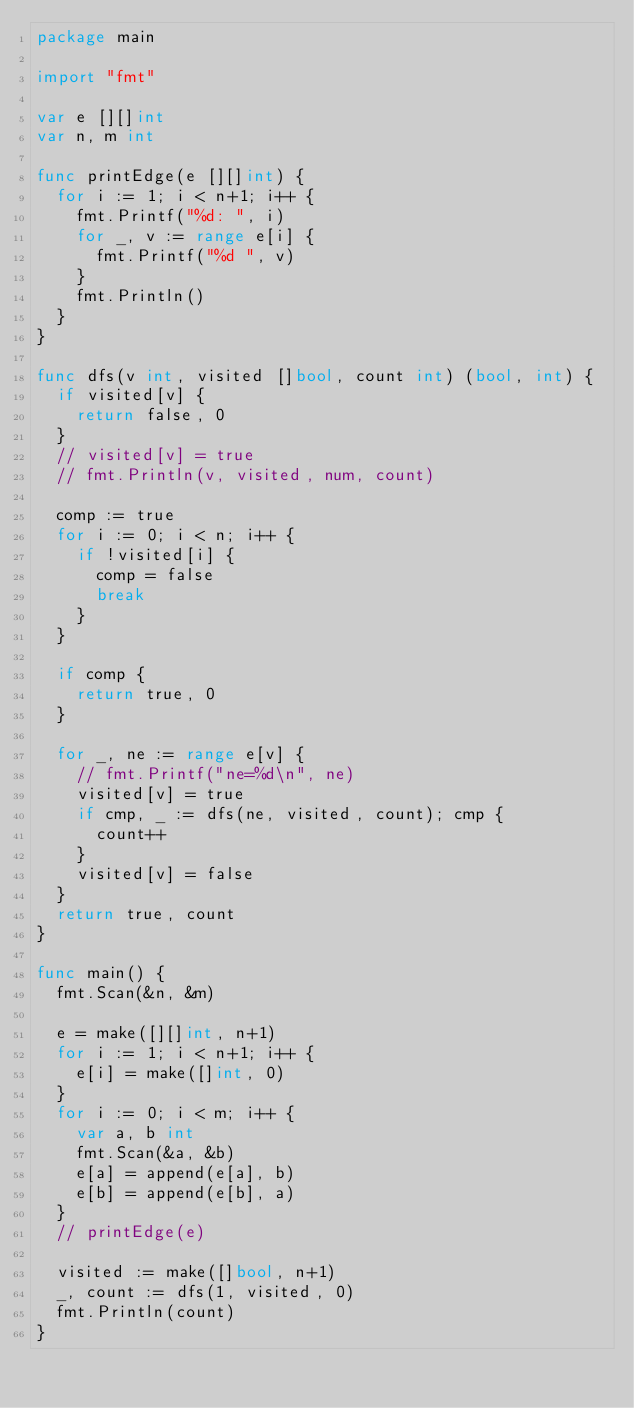Convert code to text. <code><loc_0><loc_0><loc_500><loc_500><_Go_>package main

import "fmt"

var e [][]int
var n, m int

func printEdge(e [][]int) {
	for i := 1; i < n+1; i++ {
		fmt.Printf("%d: ", i)
		for _, v := range e[i] {
			fmt.Printf("%d ", v)
		}
		fmt.Println()
	}
}

func dfs(v int, visited []bool, count int) (bool, int) {
	if visited[v] {
		return false, 0
	}
	// visited[v] = true
	// fmt.Println(v, visited, num, count)

	comp := true
	for i := 0; i < n; i++ {
		if !visited[i] {
			comp = false
			break
		}
	}

	if comp {
		return true, 0
	}

	for _, ne := range e[v] {
		// fmt.Printf("ne=%d\n", ne)
		visited[v] = true
		if cmp, _ := dfs(ne, visited, count); cmp {
			count++
		}
		visited[v] = false
	}
	return true, count
}

func main() {
	fmt.Scan(&n, &m)

	e = make([][]int, n+1)
	for i := 1; i < n+1; i++ {
		e[i] = make([]int, 0)
	}
	for i := 0; i < m; i++ {
		var a, b int
		fmt.Scan(&a, &b)
		e[a] = append(e[a], b)
		e[b] = append(e[b], a)
	}
	// printEdge(e)

	visited := make([]bool, n+1)
	_, count := dfs(1, visited, 0)
	fmt.Println(count)
}
</code> 